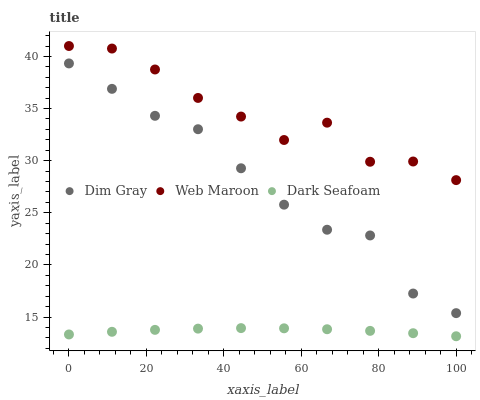Does Dark Seafoam have the minimum area under the curve?
Answer yes or no. Yes. Does Web Maroon have the maximum area under the curve?
Answer yes or no. Yes. Does Dim Gray have the minimum area under the curve?
Answer yes or no. No. Does Dim Gray have the maximum area under the curve?
Answer yes or no. No. Is Dark Seafoam the smoothest?
Answer yes or no. Yes. Is Web Maroon the roughest?
Answer yes or no. Yes. Is Dim Gray the smoothest?
Answer yes or no. No. Is Dim Gray the roughest?
Answer yes or no. No. Does Dark Seafoam have the lowest value?
Answer yes or no. Yes. Does Dim Gray have the lowest value?
Answer yes or no. No. Does Web Maroon have the highest value?
Answer yes or no. Yes. Does Dim Gray have the highest value?
Answer yes or no. No. Is Dark Seafoam less than Dim Gray?
Answer yes or no. Yes. Is Web Maroon greater than Dim Gray?
Answer yes or no. Yes. Does Dark Seafoam intersect Dim Gray?
Answer yes or no. No. 